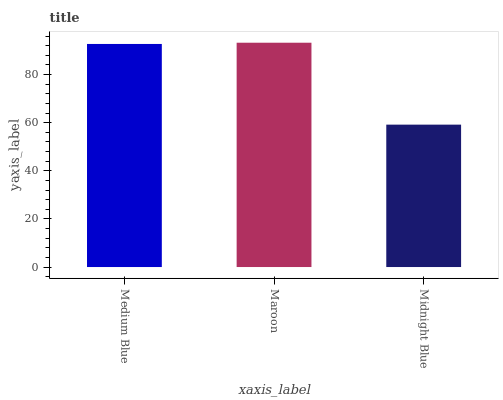Is Midnight Blue the minimum?
Answer yes or no. Yes. Is Maroon the maximum?
Answer yes or no. Yes. Is Maroon the minimum?
Answer yes or no. No. Is Midnight Blue the maximum?
Answer yes or no. No. Is Maroon greater than Midnight Blue?
Answer yes or no. Yes. Is Midnight Blue less than Maroon?
Answer yes or no. Yes. Is Midnight Blue greater than Maroon?
Answer yes or no. No. Is Maroon less than Midnight Blue?
Answer yes or no. No. Is Medium Blue the high median?
Answer yes or no. Yes. Is Medium Blue the low median?
Answer yes or no. Yes. Is Maroon the high median?
Answer yes or no. No. Is Maroon the low median?
Answer yes or no. No. 